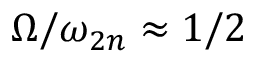<formula> <loc_0><loc_0><loc_500><loc_500>\Omega / \omega _ { 2 n } \approx 1 / 2</formula> 